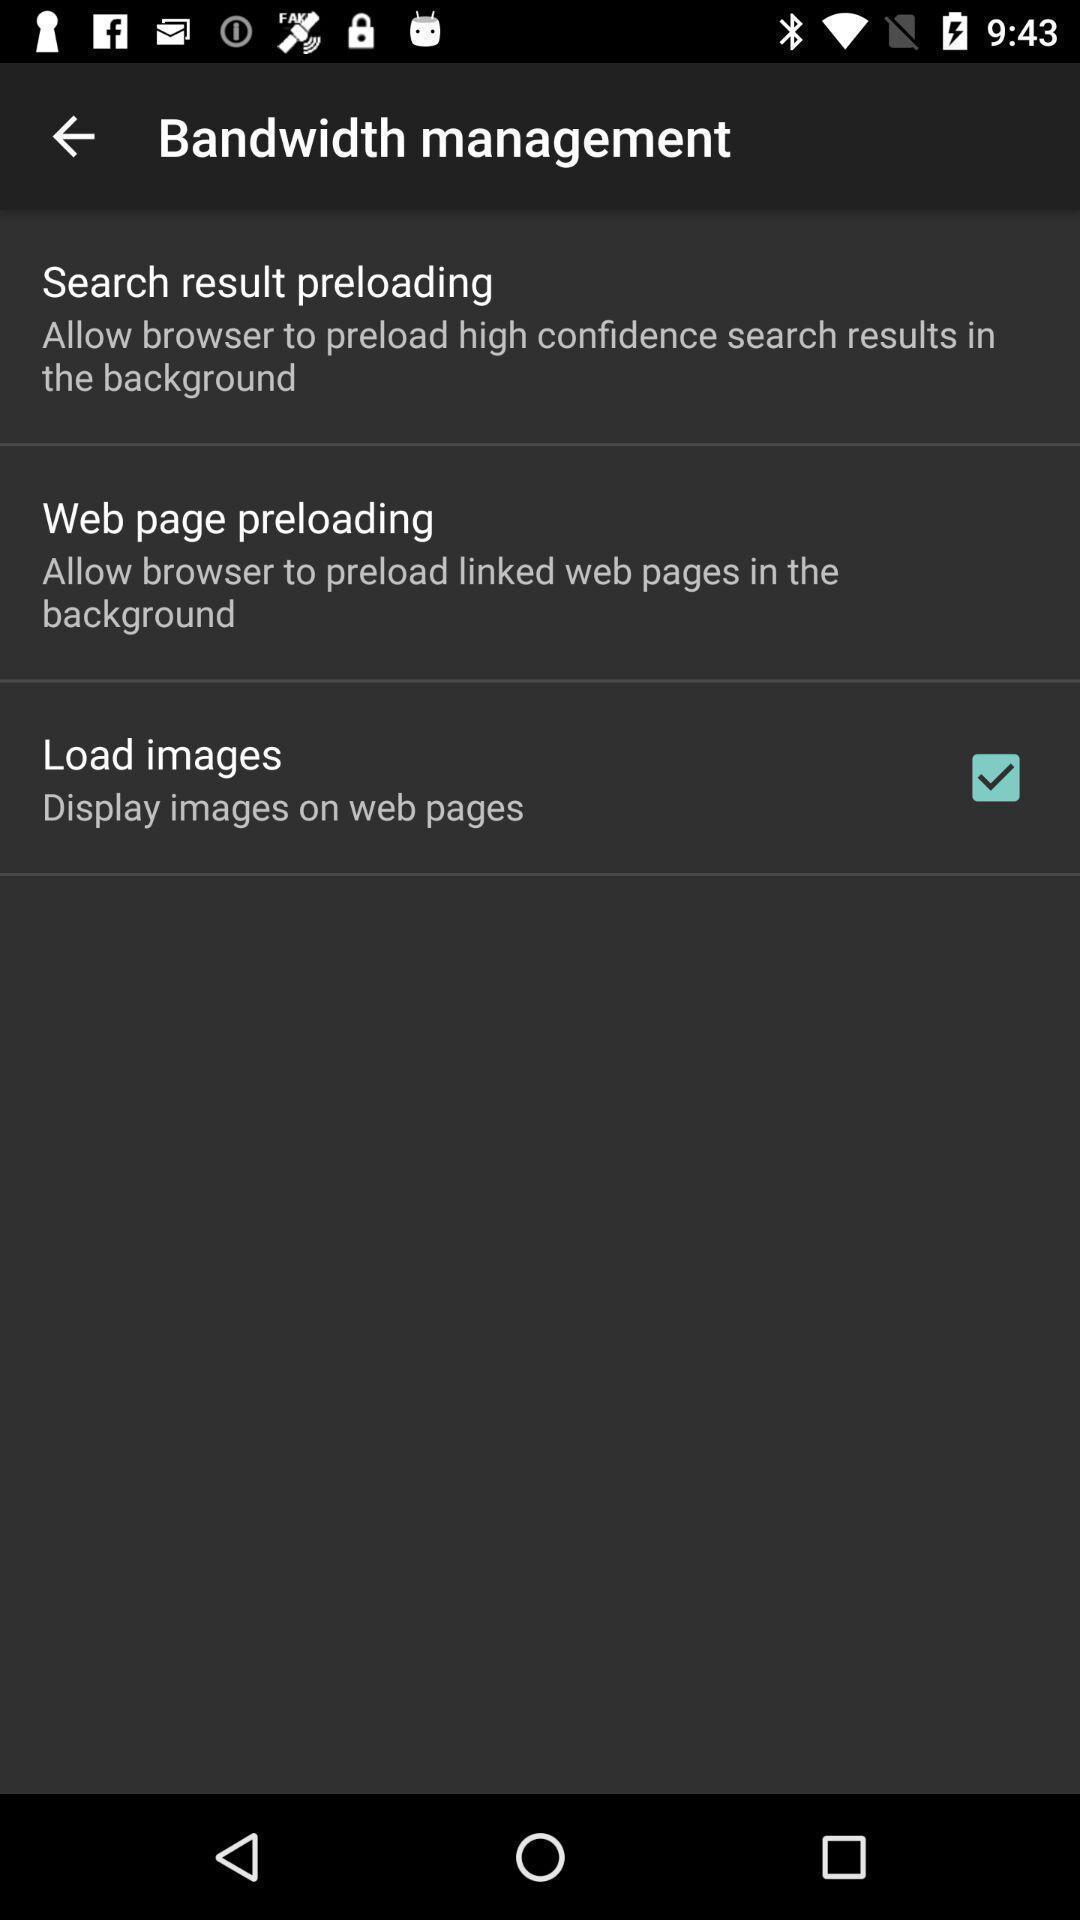Explain what's happening in this screen capture. Settings page of a browsing app. 